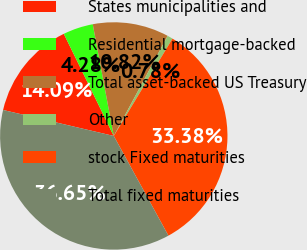Convert chart. <chart><loc_0><loc_0><loc_500><loc_500><pie_chart><fcel>States municipalities and<fcel>Residential mortgage-backed<fcel>Total asset-backed US Treasury<fcel>Other<fcel>stock Fixed maturities<fcel>Total fixed maturities<nl><fcel>14.09%<fcel>4.28%<fcel>10.82%<fcel>0.78%<fcel>33.38%<fcel>36.65%<nl></chart> 